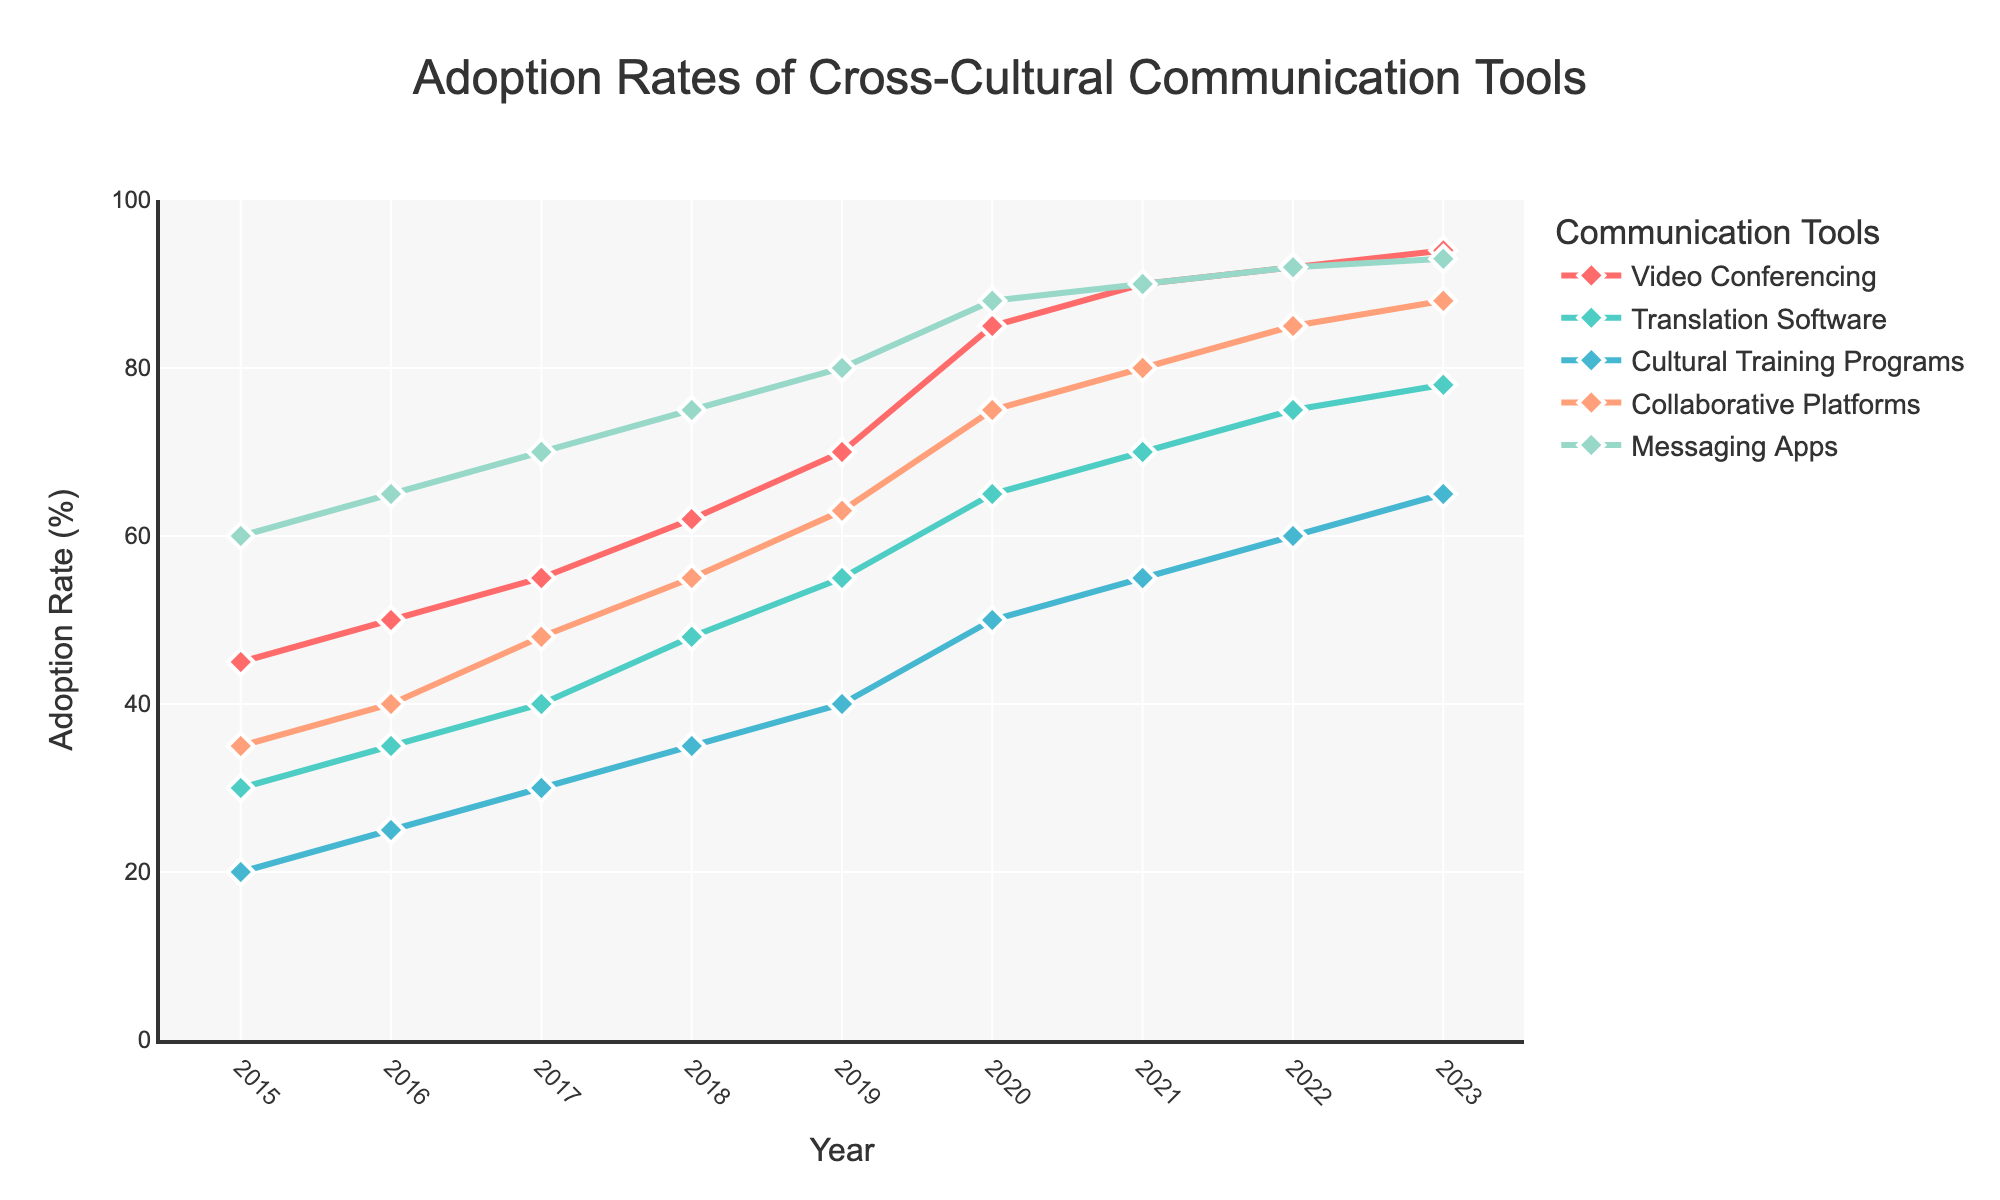What is the adoption rate of Video Conferencing in 2023? Locate the data point corresponding to 2023 on the x-axis and look at the y-value for Video Conferencing.
Answer: 94% Which communication tool had the highest adoption rate in 2017? Check the data points for all communication tools in 2017, then compare their y-values to determine which is highest.
Answer: Messaging Apps What was the rate of increase in adoption for Cultural Training Programs between 2015 and 2018? Subtract the adoption rate in 2015 (20%) from the rate in 2018 (35%).
Answer: 15% By how much did Collaborative Platforms' adoption rate increase from 2016 to 2020? Determine the difference by subtracting the 2016 adoption rate (40%) from the 2020 rate (75%).
Answer: 35% Which tool showed the most consistent increase in adoption rate over the years? Examine the slopes of the lines for all tools; the one with the most consistent slope indicates the most consistent increase.
Answer: Messaging Apps By what percentage did the adoption of Translation Software change from 2019 to 2023? Subtract the 2019 rate (55%) from the 2023 rate (78%) and calculate the percentage change.
Answer: 23% In which year did Video Conferencing surpass 80% adoption rate? Look at the data points for Video Conferencing and find the year where the rate first exceeds 80%.
Answer: 2020 What is the combined adoption rate for Messaging Apps and Video Conferencing in 2022? Add the adoption rates of Messaging Apps (92%) and Video Conferencing (92%) for 2022.
Answer: 184% Which communication tool had the steepest increase in adoption rate between any two consecutive years? Identify the largest difference between any two consecutive years for each tool and determine the steepest increase.
Answer: Video Conferencing (2019 to 2020) How many communication tools had an adoption rate of 50% or higher in 2020? Count the tools that had an adoption rate of at least 50% in the year 2020.
Answer: 5 